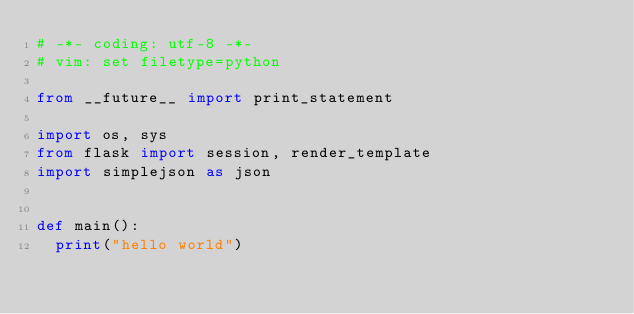<code> <loc_0><loc_0><loc_500><loc_500><_Python_># -*- coding: utf-8 -*-
# vim: set filetype=python

from __future__ import print_statement

import os, sys
from flask import session, render_template
import simplejson as json


def main():
	print("hello world")
</code> 